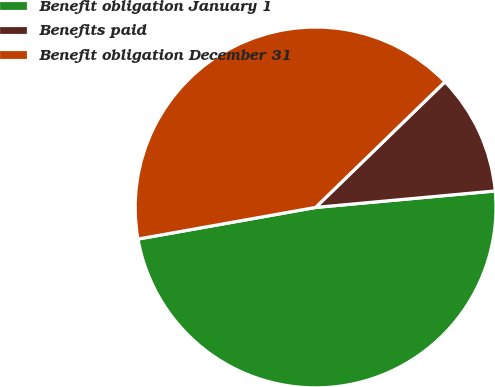<chart> <loc_0><loc_0><loc_500><loc_500><pie_chart><fcel>Benefit obligation January 1<fcel>Benefits paid<fcel>Benefit obligation December 31<nl><fcel>48.65%<fcel>10.81%<fcel>40.54%<nl></chart> 